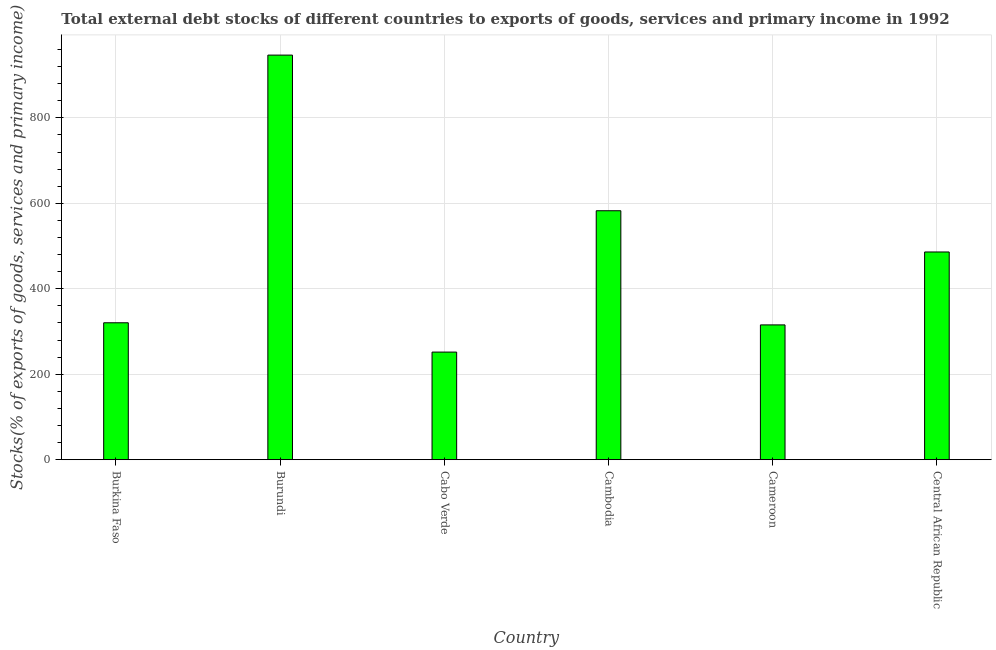Does the graph contain any zero values?
Ensure brevity in your answer.  No. What is the title of the graph?
Give a very brief answer. Total external debt stocks of different countries to exports of goods, services and primary income in 1992. What is the label or title of the X-axis?
Give a very brief answer. Country. What is the label or title of the Y-axis?
Give a very brief answer. Stocks(% of exports of goods, services and primary income). What is the external debt stocks in Cabo Verde?
Provide a short and direct response. 251.84. Across all countries, what is the maximum external debt stocks?
Keep it short and to the point. 946.86. Across all countries, what is the minimum external debt stocks?
Ensure brevity in your answer.  251.84. In which country was the external debt stocks maximum?
Your answer should be very brief. Burundi. In which country was the external debt stocks minimum?
Keep it short and to the point. Cabo Verde. What is the sum of the external debt stocks?
Offer a terse response. 2903.36. What is the difference between the external debt stocks in Burundi and Cabo Verde?
Offer a terse response. 695.01. What is the average external debt stocks per country?
Give a very brief answer. 483.89. What is the median external debt stocks?
Give a very brief answer. 403.28. What is the ratio of the external debt stocks in Cabo Verde to that in Central African Republic?
Give a very brief answer. 0.52. Is the external debt stocks in Burundi less than that in Central African Republic?
Give a very brief answer. No. Is the difference between the external debt stocks in Burkina Faso and Central African Republic greater than the difference between any two countries?
Make the answer very short. No. What is the difference between the highest and the second highest external debt stocks?
Keep it short and to the point. 364.23. What is the difference between the highest and the lowest external debt stocks?
Provide a short and direct response. 695.01. In how many countries, is the external debt stocks greater than the average external debt stocks taken over all countries?
Give a very brief answer. 3. Are the values on the major ticks of Y-axis written in scientific E-notation?
Ensure brevity in your answer.  No. What is the Stocks(% of exports of goods, services and primary income) of Burkina Faso?
Make the answer very short. 320.42. What is the Stocks(% of exports of goods, services and primary income) in Burundi?
Your answer should be very brief. 946.86. What is the Stocks(% of exports of goods, services and primary income) in Cabo Verde?
Provide a short and direct response. 251.84. What is the Stocks(% of exports of goods, services and primary income) in Cambodia?
Your answer should be very brief. 582.63. What is the Stocks(% of exports of goods, services and primary income) in Cameroon?
Provide a short and direct response. 315.47. What is the Stocks(% of exports of goods, services and primary income) in Central African Republic?
Your response must be concise. 486.14. What is the difference between the Stocks(% of exports of goods, services and primary income) in Burkina Faso and Burundi?
Give a very brief answer. -626.43. What is the difference between the Stocks(% of exports of goods, services and primary income) in Burkina Faso and Cabo Verde?
Your response must be concise. 68.58. What is the difference between the Stocks(% of exports of goods, services and primary income) in Burkina Faso and Cambodia?
Provide a short and direct response. -262.2. What is the difference between the Stocks(% of exports of goods, services and primary income) in Burkina Faso and Cameroon?
Offer a very short reply. 4.95. What is the difference between the Stocks(% of exports of goods, services and primary income) in Burkina Faso and Central African Republic?
Make the answer very short. -165.72. What is the difference between the Stocks(% of exports of goods, services and primary income) in Burundi and Cabo Verde?
Provide a short and direct response. 695.01. What is the difference between the Stocks(% of exports of goods, services and primary income) in Burundi and Cambodia?
Provide a succinct answer. 364.23. What is the difference between the Stocks(% of exports of goods, services and primary income) in Burundi and Cameroon?
Give a very brief answer. 631.39. What is the difference between the Stocks(% of exports of goods, services and primary income) in Burundi and Central African Republic?
Ensure brevity in your answer.  460.72. What is the difference between the Stocks(% of exports of goods, services and primary income) in Cabo Verde and Cambodia?
Ensure brevity in your answer.  -330.79. What is the difference between the Stocks(% of exports of goods, services and primary income) in Cabo Verde and Cameroon?
Give a very brief answer. -63.63. What is the difference between the Stocks(% of exports of goods, services and primary income) in Cabo Verde and Central African Republic?
Give a very brief answer. -234.3. What is the difference between the Stocks(% of exports of goods, services and primary income) in Cambodia and Cameroon?
Your answer should be very brief. 267.16. What is the difference between the Stocks(% of exports of goods, services and primary income) in Cambodia and Central African Republic?
Provide a succinct answer. 96.49. What is the difference between the Stocks(% of exports of goods, services and primary income) in Cameroon and Central African Republic?
Keep it short and to the point. -170.67. What is the ratio of the Stocks(% of exports of goods, services and primary income) in Burkina Faso to that in Burundi?
Your answer should be compact. 0.34. What is the ratio of the Stocks(% of exports of goods, services and primary income) in Burkina Faso to that in Cabo Verde?
Your answer should be very brief. 1.27. What is the ratio of the Stocks(% of exports of goods, services and primary income) in Burkina Faso to that in Cambodia?
Your answer should be compact. 0.55. What is the ratio of the Stocks(% of exports of goods, services and primary income) in Burkina Faso to that in Cameroon?
Offer a terse response. 1.02. What is the ratio of the Stocks(% of exports of goods, services and primary income) in Burkina Faso to that in Central African Republic?
Provide a succinct answer. 0.66. What is the ratio of the Stocks(% of exports of goods, services and primary income) in Burundi to that in Cabo Verde?
Your answer should be very brief. 3.76. What is the ratio of the Stocks(% of exports of goods, services and primary income) in Burundi to that in Cambodia?
Give a very brief answer. 1.62. What is the ratio of the Stocks(% of exports of goods, services and primary income) in Burundi to that in Cameroon?
Offer a very short reply. 3. What is the ratio of the Stocks(% of exports of goods, services and primary income) in Burundi to that in Central African Republic?
Your answer should be compact. 1.95. What is the ratio of the Stocks(% of exports of goods, services and primary income) in Cabo Verde to that in Cambodia?
Provide a short and direct response. 0.43. What is the ratio of the Stocks(% of exports of goods, services and primary income) in Cabo Verde to that in Cameroon?
Make the answer very short. 0.8. What is the ratio of the Stocks(% of exports of goods, services and primary income) in Cabo Verde to that in Central African Republic?
Your answer should be very brief. 0.52. What is the ratio of the Stocks(% of exports of goods, services and primary income) in Cambodia to that in Cameroon?
Offer a very short reply. 1.85. What is the ratio of the Stocks(% of exports of goods, services and primary income) in Cambodia to that in Central African Republic?
Your answer should be compact. 1.2. What is the ratio of the Stocks(% of exports of goods, services and primary income) in Cameroon to that in Central African Republic?
Make the answer very short. 0.65. 